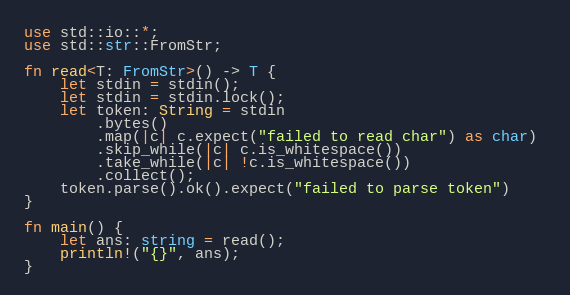<code> <loc_0><loc_0><loc_500><loc_500><_Rust_>use std::io::*;
use std::str::FromStr;

fn read<T: FromStr>() -> T {
    let stdin = stdin();
    let stdin = stdin.lock();
    let token: String = stdin
        .bytes()
        .map(|c| c.expect("failed to read char") as char) 
        .skip_while(|c| c.is_whitespace())
        .take_while(|c| !c.is_whitespace())
        .collect();
    token.parse().ok().expect("failed to parse token")
}

fn main() {
    let ans: string = read();
    println!("{}", ans);
}</code> 